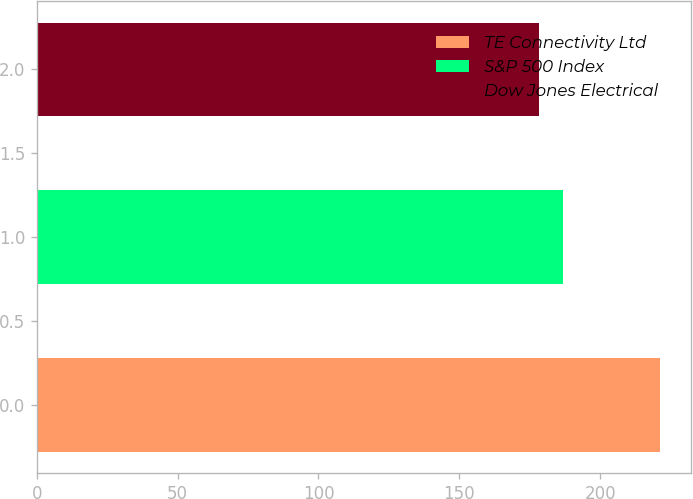Convert chart. <chart><loc_0><loc_0><loc_500><loc_500><bar_chart><fcel>TE Connectivity Ltd<fcel>S&P 500 Index<fcel>Dow Jones Electrical<nl><fcel>221.28<fcel>186.88<fcel>178.41<nl></chart> 